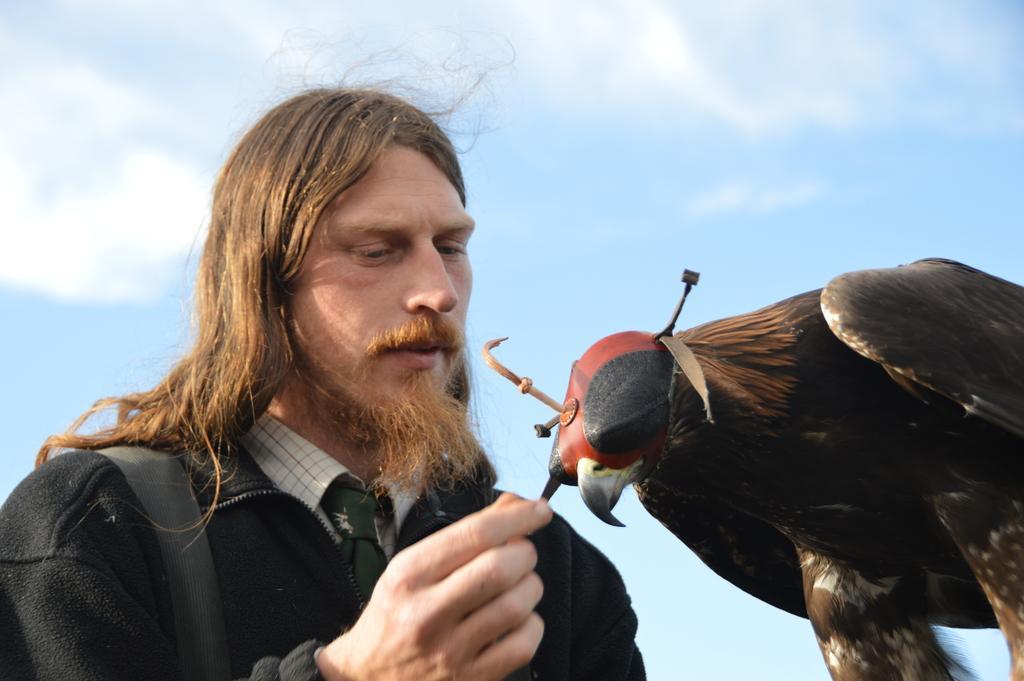Could you give a brief overview of what you see in this image? In this image we can see a man and a bird. In the background there is sky with clouds. 